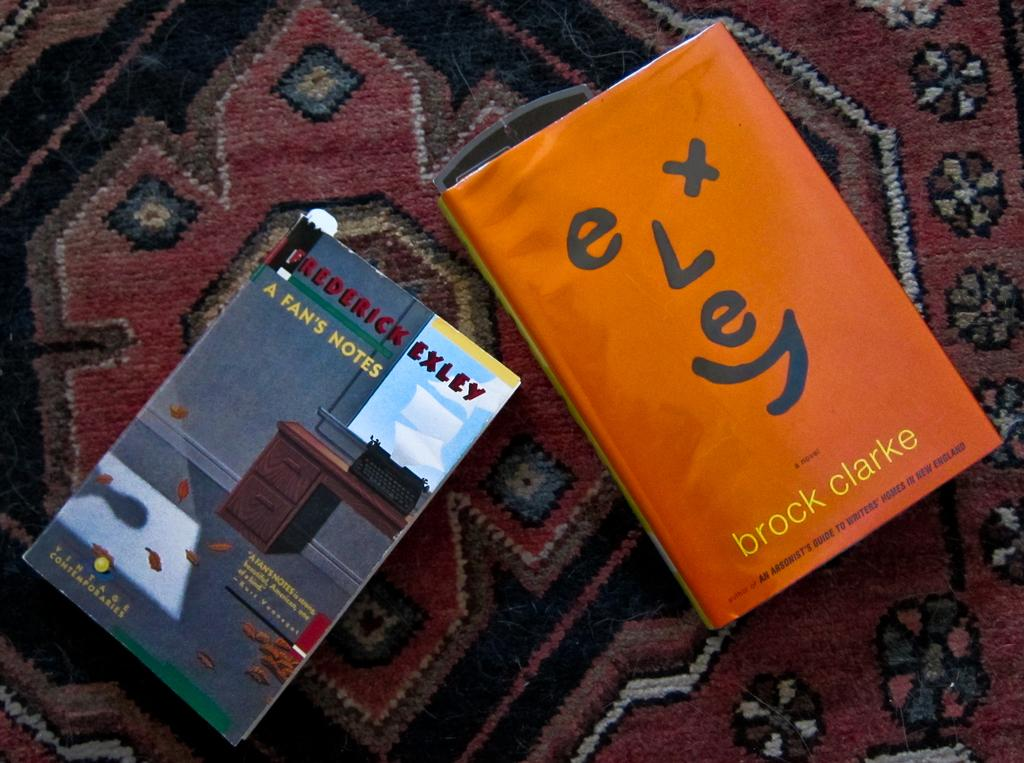<image>
Describe the image concisely. Two books sit on a carpet, one of them is written by Brock Clarke. 